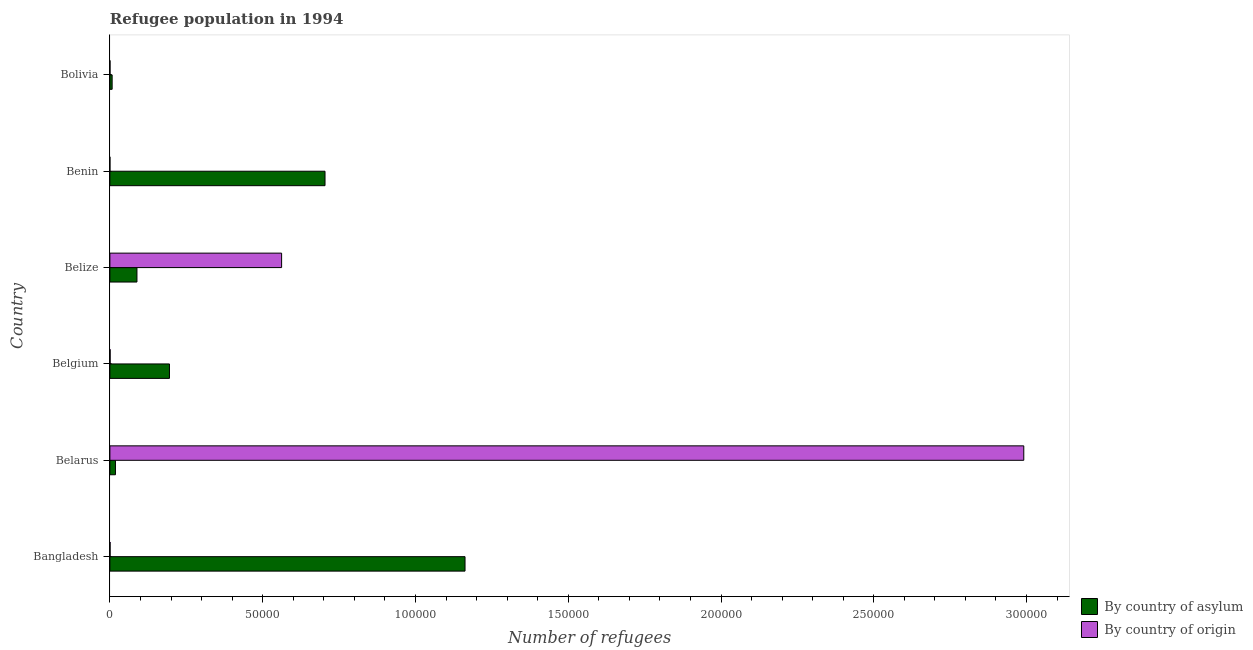How many different coloured bars are there?
Offer a terse response. 2. How many groups of bars are there?
Provide a short and direct response. 6. How many bars are there on the 6th tick from the top?
Your answer should be compact. 2. How many bars are there on the 2nd tick from the bottom?
Give a very brief answer. 2. What is the label of the 6th group of bars from the top?
Keep it short and to the point. Bangladesh. In how many cases, is the number of bars for a given country not equal to the number of legend labels?
Provide a short and direct response. 0. What is the number of refugees by country of asylum in Benin?
Ensure brevity in your answer.  7.04e+04. Across all countries, what is the maximum number of refugees by country of asylum?
Your answer should be very brief. 1.16e+05. Across all countries, what is the minimum number of refugees by country of asylum?
Provide a succinct answer. 734. What is the total number of refugees by country of asylum in the graph?
Offer a very short reply. 2.18e+05. What is the difference between the number of refugees by country of origin in Belgium and that in Belize?
Your answer should be very brief. -5.61e+04. What is the difference between the number of refugees by country of asylum in Benin and the number of refugees by country of origin in Belize?
Offer a very short reply. 1.42e+04. What is the average number of refugees by country of asylum per country?
Your response must be concise. 3.63e+04. What is the difference between the number of refugees by country of origin and number of refugees by country of asylum in Bangladesh?
Provide a short and direct response. -1.16e+05. What is the ratio of the number of refugees by country of origin in Belarus to that in Belgium?
Offer a terse response. 3987.93. What is the difference between the highest and the second highest number of refugees by country of asylum?
Offer a terse response. 4.58e+04. What is the difference between the highest and the lowest number of refugees by country of origin?
Your answer should be very brief. 2.99e+05. What does the 2nd bar from the top in Belize represents?
Your answer should be very brief. By country of asylum. What does the 2nd bar from the bottom in Belarus represents?
Your answer should be very brief. By country of origin. How many bars are there?
Make the answer very short. 12. Are all the bars in the graph horizontal?
Offer a very short reply. Yes. How many countries are there in the graph?
Offer a very short reply. 6. Are the values on the major ticks of X-axis written in scientific E-notation?
Your response must be concise. No. Does the graph contain any zero values?
Offer a very short reply. No. Does the graph contain grids?
Your answer should be compact. No. What is the title of the graph?
Provide a succinct answer. Refugee population in 1994. What is the label or title of the X-axis?
Ensure brevity in your answer.  Number of refugees. What is the label or title of the Y-axis?
Provide a short and direct response. Country. What is the Number of refugees of By country of asylum in Bangladesh?
Give a very brief answer. 1.16e+05. What is the Number of refugees of By country of asylum in Belarus?
Ensure brevity in your answer.  1822. What is the Number of refugees of By country of origin in Belarus?
Keep it short and to the point. 2.99e+05. What is the Number of refugees in By country of asylum in Belgium?
Your answer should be very brief. 1.95e+04. What is the Number of refugees of By country of asylum in Belize?
Keep it short and to the point. 8857. What is the Number of refugees in By country of origin in Belize?
Keep it short and to the point. 5.62e+04. What is the Number of refugees in By country of asylum in Benin?
Your answer should be very brief. 7.04e+04. What is the Number of refugees of By country of origin in Benin?
Your answer should be compact. 4. What is the Number of refugees in By country of asylum in Bolivia?
Ensure brevity in your answer.  734. What is the Number of refugees in By country of origin in Bolivia?
Give a very brief answer. 37. Across all countries, what is the maximum Number of refugees in By country of asylum?
Offer a very short reply. 1.16e+05. Across all countries, what is the maximum Number of refugees in By country of origin?
Offer a very short reply. 2.99e+05. Across all countries, what is the minimum Number of refugees of By country of asylum?
Your response must be concise. 734. Across all countries, what is the minimum Number of refugees of By country of origin?
Offer a very short reply. 4. What is the total Number of refugees in By country of asylum in the graph?
Give a very brief answer. 2.18e+05. What is the total Number of refugees of By country of origin in the graph?
Keep it short and to the point. 3.55e+05. What is the difference between the Number of refugees of By country of asylum in Bangladesh and that in Belarus?
Give a very brief answer. 1.14e+05. What is the difference between the Number of refugees in By country of origin in Bangladesh and that in Belarus?
Provide a succinct answer. -2.99e+05. What is the difference between the Number of refugees in By country of asylum in Bangladesh and that in Belgium?
Make the answer very short. 9.67e+04. What is the difference between the Number of refugees in By country of asylum in Bangladesh and that in Belize?
Offer a terse response. 1.07e+05. What is the difference between the Number of refugees of By country of origin in Bangladesh and that in Belize?
Give a very brief answer. -5.61e+04. What is the difference between the Number of refugees of By country of asylum in Bangladesh and that in Benin?
Your answer should be compact. 4.58e+04. What is the difference between the Number of refugees in By country of asylum in Bangladesh and that in Bolivia?
Make the answer very short. 1.15e+05. What is the difference between the Number of refugees in By country of origin in Bangladesh and that in Bolivia?
Make the answer very short. 23. What is the difference between the Number of refugees of By country of asylum in Belarus and that in Belgium?
Your answer should be very brief. -1.77e+04. What is the difference between the Number of refugees of By country of origin in Belarus and that in Belgium?
Your response must be concise. 2.99e+05. What is the difference between the Number of refugees in By country of asylum in Belarus and that in Belize?
Give a very brief answer. -7035. What is the difference between the Number of refugees in By country of origin in Belarus and that in Belize?
Keep it short and to the point. 2.43e+05. What is the difference between the Number of refugees of By country of asylum in Belarus and that in Benin?
Your answer should be compact. -6.86e+04. What is the difference between the Number of refugees of By country of origin in Belarus and that in Benin?
Offer a very short reply. 2.99e+05. What is the difference between the Number of refugees of By country of asylum in Belarus and that in Bolivia?
Ensure brevity in your answer.  1088. What is the difference between the Number of refugees in By country of origin in Belarus and that in Bolivia?
Your response must be concise. 2.99e+05. What is the difference between the Number of refugees of By country of asylum in Belgium and that in Belize?
Offer a very short reply. 1.06e+04. What is the difference between the Number of refugees in By country of origin in Belgium and that in Belize?
Give a very brief answer. -5.61e+04. What is the difference between the Number of refugees in By country of asylum in Belgium and that in Benin?
Offer a terse response. -5.09e+04. What is the difference between the Number of refugees of By country of origin in Belgium and that in Benin?
Provide a short and direct response. 71. What is the difference between the Number of refugees of By country of asylum in Belgium and that in Bolivia?
Provide a short and direct response. 1.88e+04. What is the difference between the Number of refugees of By country of asylum in Belize and that in Benin?
Offer a terse response. -6.15e+04. What is the difference between the Number of refugees in By country of origin in Belize and that in Benin?
Your answer should be compact. 5.62e+04. What is the difference between the Number of refugees in By country of asylum in Belize and that in Bolivia?
Your answer should be compact. 8123. What is the difference between the Number of refugees in By country of origin in Belize and that in Bolivia?
Keep it short and to the point. 5.62e+04. What is the difference between the Number of refugees in By country of asylum in Benin and that in Bolivia?
Give a very brief answer. 6.97e+04. What is the difference between the Number of refugees in By country of origin in Benin and that in Bolivia?
Offer a very short reply. -33. What is the difference between the Number of refugees in By country of asylum in Bangladesh and the Number of refugees in By country of origin in Belarus?
Your response must be concise. -1.83e+05. What is the difference between the Number of refugees of By country of asylum in Bangladesh and the Number of refugees of By country of origin in Belgium?
Make the answer very short. 1.16e+05. What is the difference between the Number of refugees of By country of asylum in Bangladesh and the Number of refugees of By country of origin in Belize?
Keep it short and to the point. 6.00e+04. What is the difference between the Number of refugees in By country of asylum in Bangladesh and the Number of refugees in By country of origin in Benin?
Offer a very short reply. 1.16e+05. What is the difference between the Number of refugees in By country of asylum in Bangladesh and the Number of refugees in By country of origin in Bolivia?
Provide a short and direct response. 1.16e+05. What is the difference between the Number of refugees of By country of asylum in Belarus and the Number of refugees of By country of origin in Belgium?
Provide a short and direct response. 1747. What is the difference between the Number of refugees in By country of asylum in Belarus and the Number of refugees in By country of origin in Belize?
Offer a very short reply. -5.44e+04. What is the difference between the Number of refugees in By country of asylum in Belarus and the Number of refugees in By country of origin in Benin?
Offer a very short reply. 1818. What is the difference between the Number of refugees in By country of asylum in Belarus and the Number of refugees in By country of origin in Bolivia?
Ensure brevity in your answer.  1785. What is the difference between the Number of refugees in By country of asylum in Belgium and the Number of refugees in By country of origin in Belize?
Ensure brevity in your answer.  -3.67e+04. What is the difference between the Number of refugees of By country of asylum in Belgium and the Number of refugees of By country of origin in Benin?
Provide a succinct answer. 1.95e+04. What is the difference between the Number of refugees in By country of asylum in Belgium and the Number of refugees in By country of origin in Bolivia?
Your answer should be compact. 1.95e+04. What is the difference between the Number of refugees of By country of asylum in Belize and the Number of refugees of By country of origin in Benin?
Ensure brevity in your answer.  8853. What is the difference between the Number of refugees of By country of asylum in Belize and the Number of refugees of By country of origin in Bolivia?
Give a very brief answer. 8820. What is the difference between the Number of refugees of By country of asylum in Benin and the Number of refugees of By country of origin in Bolivia?
Ensure brevity in your answer.  7.04e+04. What is the average Number of refugees in By country of asylum per country?
Provide a short and direct response. 3.63e+04. What is the average Number of refugees in By country of origin per country?
Give a very brief answer. 5.92e+04. What is the difference between the Number of refugees of By country of asylum and Number of refugees of By country of origin in Bangladesh?
Your answer should be very brief. 1.16e+05. What is the difference between the Number of refugees in By country of asylum and Number of refugees in By country of origin in Belarus?
Offer a very short reply. -2.97e+05. What is the difference between the Number of refugees of By country of asylum and Number of refugees of By country of origin in Belgium?
Your answer should be very brief. 1.94e+04. What is the difference between the Number of refugees of By country of asylum and Number of refugees of By country of origin in Belize?
Keep it short and to the point. -4.73e+04. What is the difference between the Number of refugees of By country of asylum and Number of refugees of By country of origin in Benin?
Keep it short and to the point. 7.04e+04. What is the difference between the Number of refugees in By country of asylum and Number of refugees in By country of origin in Bolivia?
Provide a short and direct response. 697. What is the ratio of the Number of refugees of By country of asylum in Bangladesh to that in Belarus?
Keep it short and to the point. 63.79. What is the ratio of the Number of refugees of By country of asylum in Bangladesh to that in Belgium?
Ensure brevity in your answer.  5.96. What is the ratio of the Number of refugees in By country of asylum in Bangladesh to that in Belize?
Keep it short and to the point. 13.12. What is the ratio of the Number of refugees in By country of origin in Bangladesh to that in Belize?
Make the answer very short. 0. What is the ratio of the Number of refugees of By country of asylum in Bangladesh to that in Benin?
Your answer should be very brief. 1.65. What is the ratio of the Number of refugees of By country of asylum in Bangladesh to that in Bolivia?
Provide a short and direct response. 158.35. What is the ratio of the Number of refugees of By country of origin in Bangladesh to that in Bolivia?
Your response must be concise. 1.62. What is the ratio of the Number of refugees of By country of asylum in Belarus to that in Belgium?
Ensure brevity in your answer.  0.09. What is the ratio of the Number of refugees in By country of origin in Belarus to that in Belgium?
Keep it short and to the point. 3987.93. What is the ratio of the Number of refugees of By country of asylum in Belarus to that in Belize?
Make the answer very short. 0.21. What is the ratio of the Number of refugees in By country of origin in Belarus to that in Belize?
Your answer should be compact. 5.32. What is the ratio of the Number of refugees in By country of asylum in Belarus to that in Benin?
Your response must be concise. 0.03. What is the ratio of the Number of refugees of By country of origin in Belarus to that in Benin?
Your answer should be compact. 7.48e+04. What is the ratio of the Number of refugees of By country of asylum in Belarus to that in Bolivia?
Give a very brief answer. 2.48. What is the ratio of the Number of refugees of By country of origin in Belarus to that in Bolivia?
Keep it short and to the point. 8083.65. What is the ratio of the Number of refugees of By country of asylum in Belgium to that in Belize?
Offer a very short reply. 2.2. What is the ratio of the Number of refugees in By country of origin in Belgium to that in Belize?
Offer a very short reply. 0. What is the ratio of the Number of refugees in By country of asylum in Belgium to that in Benin?
Offer a very short reply. 0.28. What is the ratio of the Number of refugees of By country of origin in Belgium to that in Benin?
Your answer should be very brief. 18.75. What is the ratio of the Number of refugees of By country of asylum in Belgium to that in Bolivia?
Provide a succinct answer. 26.56. What is the ratio of the Number of refugees of By country of origin in Belgium to that in Bolivia?
Make the answer very short. 2.03. What is the ratio of the Number of refugees of By country of asylum in Belize to that in Benin?
Your answer should be compact. 0.13. What is the ratio of the Number of refugees of By country of origin in Belize to that in Benin?
Your response must be concise. 1.40e+04. What is the ratio of the Number of refugees in By country of asylum in Belize to that in Bolivia?
Your response must be concise. 12.07. What is the ratio of the Number of refugees of By country of origin in Belize to that in Bolivia?
Give a very brief answer. 1518.89. What is the ratio of the Number of refugees in By country of asylum in Benin to that in Bolivia?
Provide a short and direct response. 95.92. What is the ratio of the Number of refugees in By country of origin in Benin to that in Bolivia?
Provide a succinct answer. 0.11. What is the difference between the highest and the second highest Number of refugees in By country of asylum?
Your answer should be very brief. 4.58e+04. What is the difference between the highest and the second highest Number of refugees in By country of origin?
Offer a very short reply. 2.43e+05. What is the difference between the highest and the lowest Number of refugees in By country of asylum?
Your answer should be very brief. 1.15e+05. What is the difference between the highest and the lowest Number of refugees in By country of origin?
Offer a terse response. 2.99e+05. 